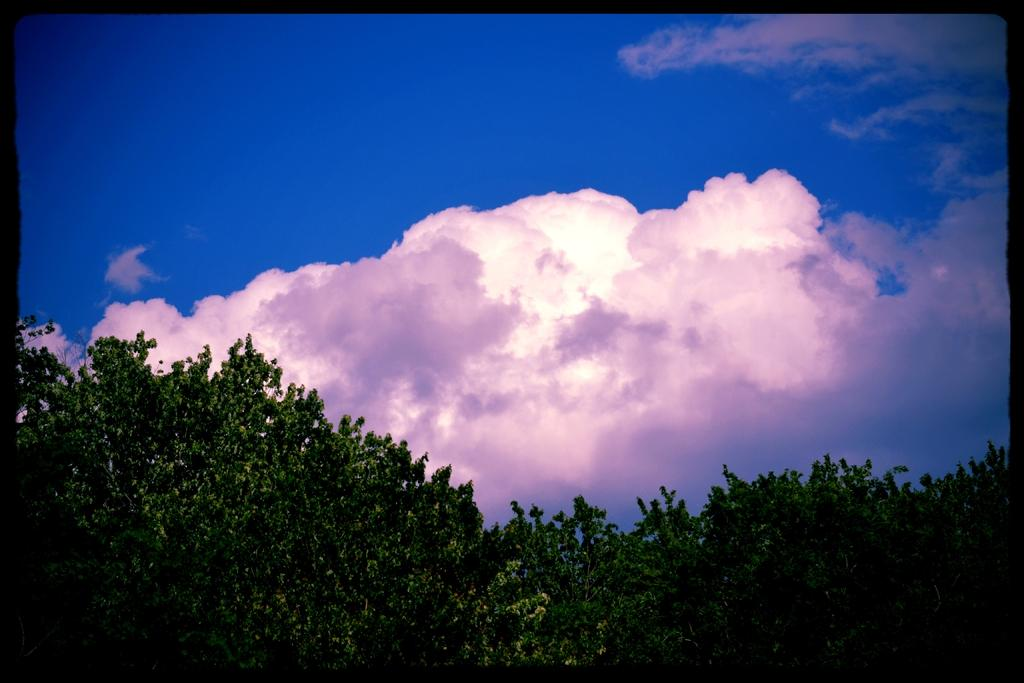What type of vegetation can be seen at the bottom of the image? There are trees at the bottom of the image. What is visible at the top of the image? The sky is visible at the top of the image. What can be observed in the sky? Clouds are present in the sky. What type of expansion is taking place in the image? There is no expansion present in the image; it features trees, sky, and clouds. Can you see a balloon in the image? There is no balloon present in the image. 